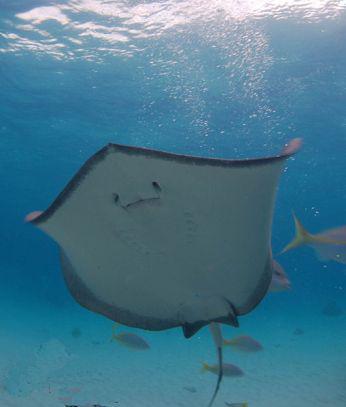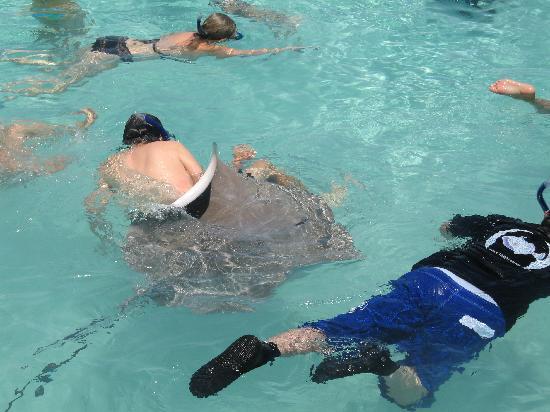The first image is the image on the left, the second image is the image on the right. Given the left and right images, does the statement "One image shows at least one person in the water with a stingray." hold true? Answer yes or no. Yes. The first image is the image on the left, the second image is the image on the right. Considering the images on both sides, is "One image in the pair has a human." valid? Answer yes or no. Yes. 